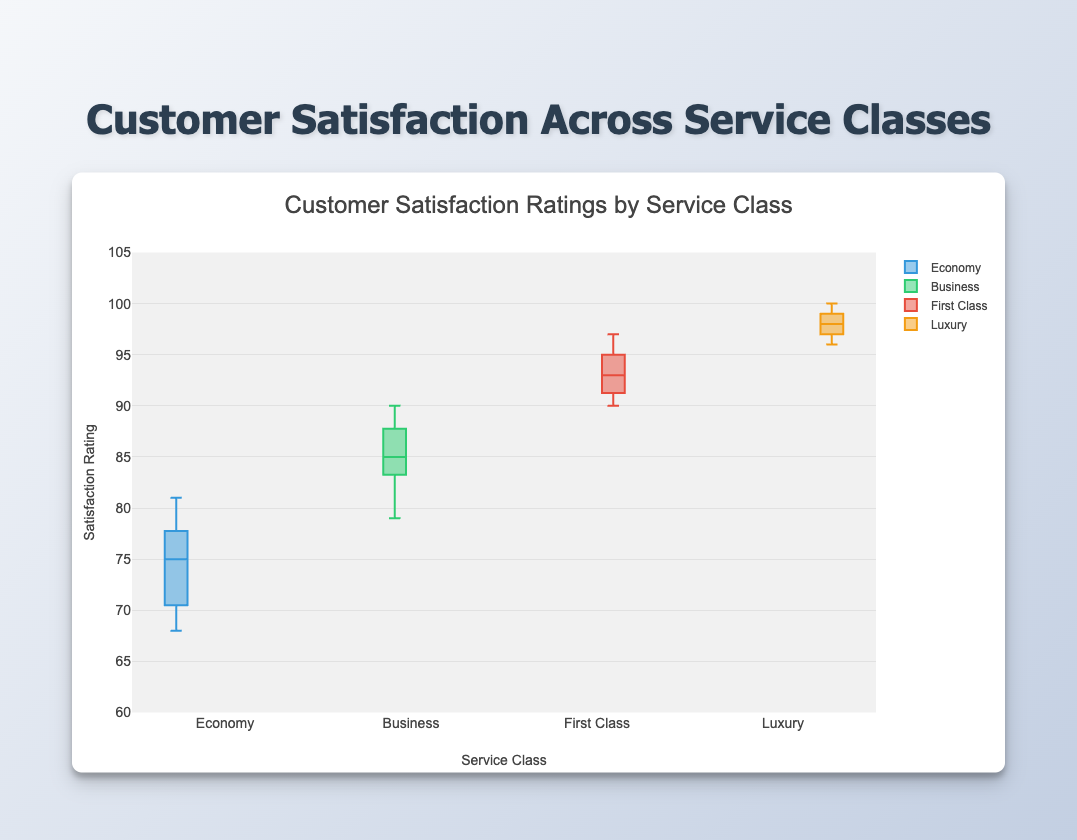What's the title of the plot? The title of the plot is a textual element displayed at the top of the figure to describe its content.
Answer: Customer Satisfaction Across Service Classes What is the range of the y-axis? The range of the y-axis indicates the span of values shown from the bottom to the top of the axis. By examining the plot, the y-axis starts at 60 and ends at 105.
Answer: 60 to 105 Which service class has the highest median customer satisfaction rating? The median is represented by the line within each box plot. By observing the position of the median lines, Luxury has the highest median.
Answer: Luxury What is the minimum satisfaction rating in the Luxury class? The minimum rating in a box plot is represented by the bottom whisker or the lowest point. For Luxury, it is at 96.
Answer: 96 How many service classes are displayed in the plot? The number of service classes is determined by counting the distinct box plots. There are four box plots corresponding to Economy, Business, First Class, and Luxury.
Answer: 4 In which service class do we observe the largest range in customer satisfaction ratings? The range is the difference between the maximum and minimum values within each box plot. By comparing the length of the whiskers, Business has the largest range from 79 to 90.
Answer: Business What's the median value of customer satisfaction ratings for Economy class? The median value is shown by the line inside the box of the Economy class, which is at 75.
Answer: 75 How does the interquartile range (IQR) of Business class compare to First Class? IQR is the difference between the third quartile (top of the box) and the first quartile (bottom of the box). For Business, the IQR is from 83 to 88 (5 units), and for First Class, it is from 91 to 95 (4 units). Business has a larger IQR.
Answer: Business has a larger IQR Which service class has the highest variability in customer satisfaction ratings? Variability can be inferred from the range and the spread of data. Business class shows the largest range, suggesting higher variability.
Answer: Business 